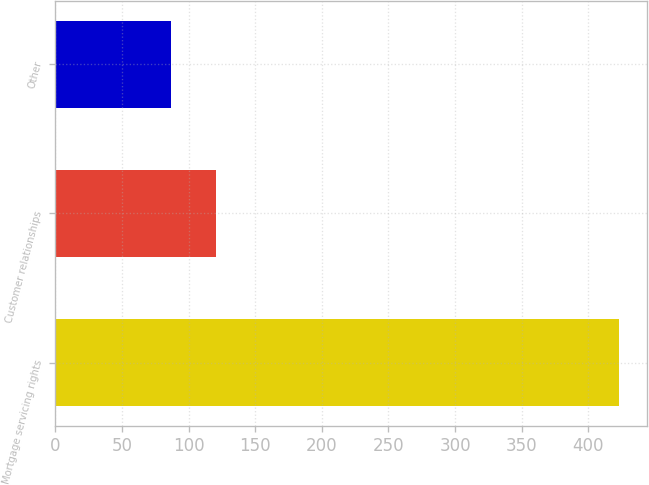Convert chart. <chart><loc_0><loc_0><loc_500><loc_500><bar_chart><fcel>Mortgage servicing rights<fcel>Customer relationships<fcel>Other<nl><fcel>423<fcel>120.6<fcel>87<nl></chart> 